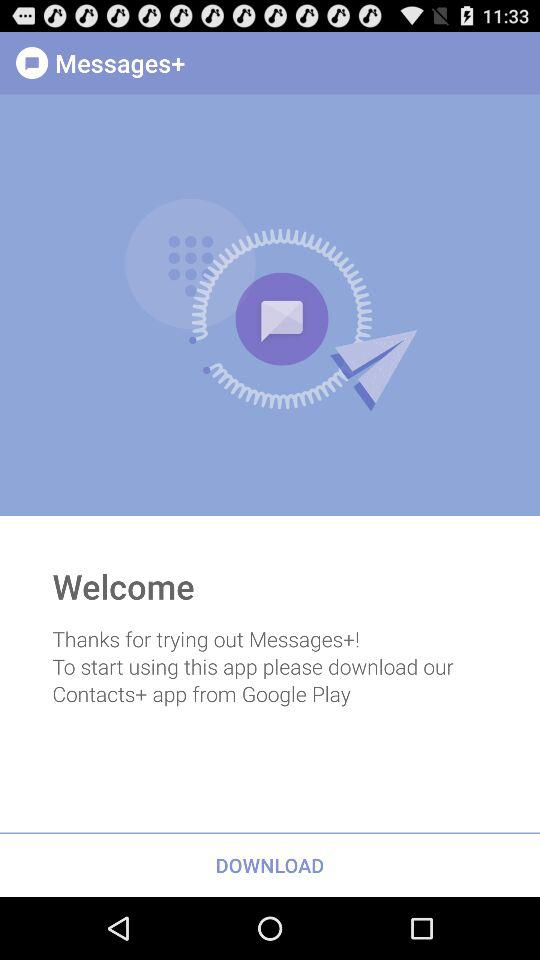What is the app name? The app name is "Messages+". 